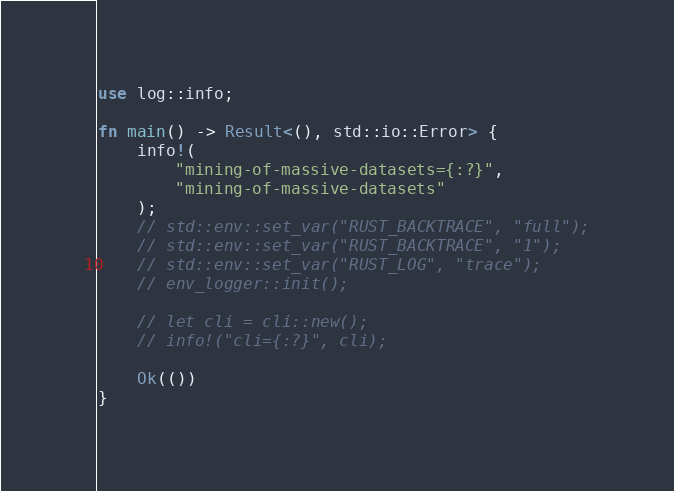<code> <loc_0><loc_0><loc_500><loc_500><_Rust_>use log::info;

fn main() -> Result<(), std::io::Error> {
    info!(
        "mining-of-massive-datasets={:?}",
        "mining-of-massive-datasets"
    );
    // std::env::set_var("RUST_BACKTRACE", "full");
    // std::env::set_var("RUST_BACKTRACE", "1");
    // std::env::set_var("RUST_LOG", "trace");
    // env_logger::init();

    // let cli = cli::new();
    // info!("cli={:?}", cli);

    Ok(())
}
</code> 